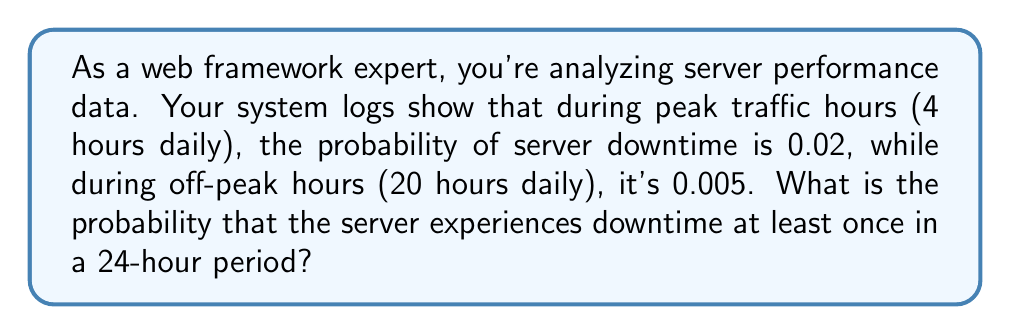Provide a solution to this math problem. Let's approach this step-by-step:

1) First, we need to calculate the probability of no downtime during peak and off-peak hours separately.

2) For peak hours (4 hours):
   Probability of no downtime = $1 - 0.02 = 0.98$
   Probability of no downtime for all 4 hours = $0.98^4 = 0.9224$

3) For off-peak hours (20 hours):
   Probability of no downtime = $1 - 0.005 = 0.995$
   Probability of no downtime for all 20 hours = $0.995^{20} = 0.9048$

4) The probability of no downtime for the entire day is the product of these probabilities:
   $P(\text{no downtime}) = 0.9224 \times 0.9048 = 0.8346$

5) Therefore, the probability of at least one downtime in 24 hours is:
   $P(\text{at least one downtime}) = 1 - P(\text{no downtime}) = 1 - 0.8346 = 0.1654$

6) Converting to a percentage: $0.1654 \times 100 = 16.54\%$
Answer: $16.54\%$ 